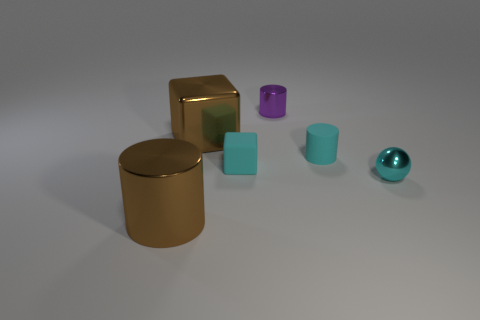Add 1 large red shiny objects. How many objects exist? 7 Subtract all balls. How many objects are left? 5 Add 3 cyan cylinders. How many cyan cylinders are left? 4 Add 5 tiny cyan cylinders. How many tiny cyan cylinders exist? 6 Subtract 0 gray balls. How many objects are left? 6 Subtract all red rubber cylinders. Subtract all brown things. How many objects are left? 4 